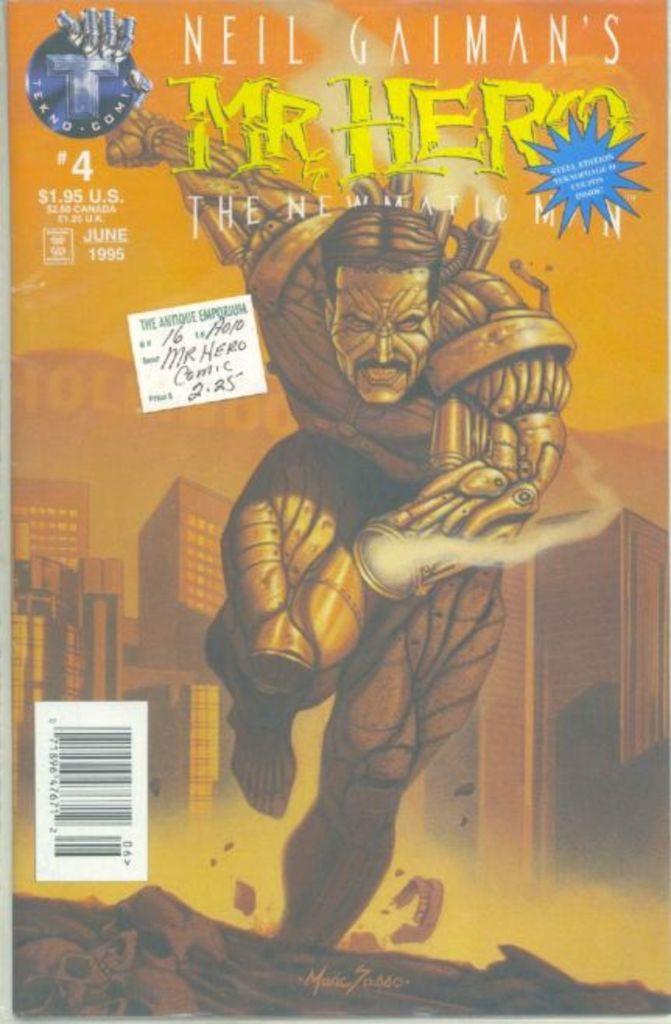Who wrote this comic?
Keep it short and to the point. Neil gaiman. 